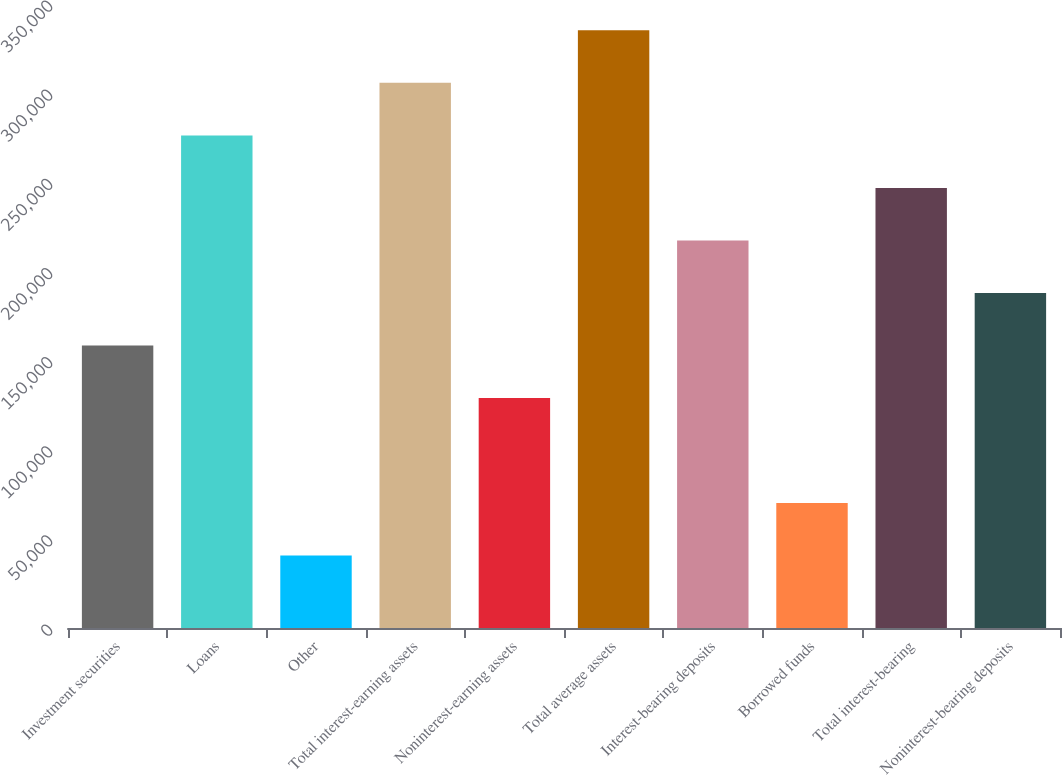Convert chart to OTSL. <chart><loc_0><loc_0><loc_500><loc_500><bar_chart><fcel>Investment securities<fcel>Loans<fcel>Other<fcel>Total interest-earning assets<fcel>Noninterest-earning assets<fcel>Total average assets<fcel>Interest-bearing deposits<fcel>Borrowed funds<fcel>Total interest-bearing<fcel>Noninterest-bearing deposits<nl><fcel>158484<fcel>276310<fcel>40658.4<fcel>305766<fcel>129028<fcel>335222<fcel>217397<fcel>70114.8<fcel>246853<fcel>187940<nl></chart> 